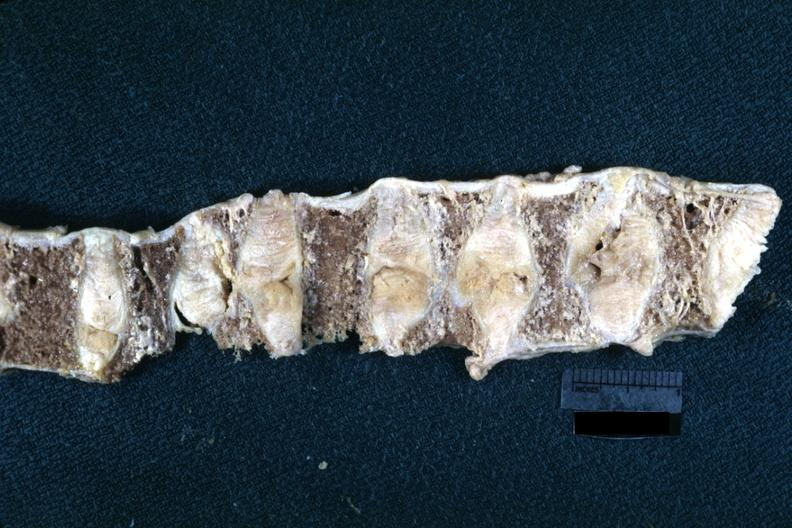what is this lesion?
Answer the question using a single word or phrase. Probably due to osteoporosis 